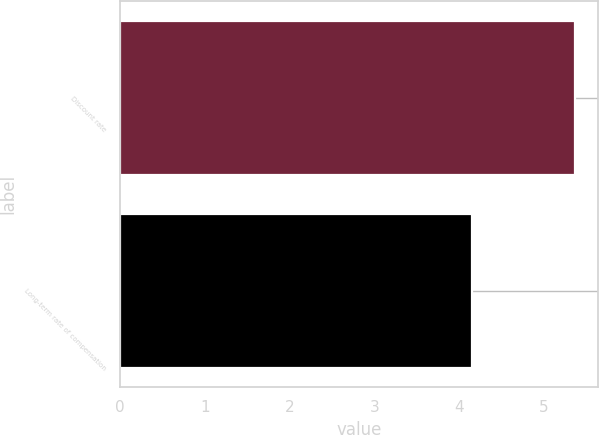Convert chart to OTSL. <chart><loc_0><loc_0><loc_500><loc_500><bar_chart><fcel>Discount rate<fcel>Long-term rate of compensation<nl><fcel>5.37<fcel>4.16<nl></chart> 